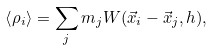<formula> <loc_0><loc_0><loc_500><loc_500>\left < \rho _ { i } \right > = \sum _ { j } m _ { j } W ( { \vec { x } _ { i } } - { \vec { x } _ { j } } , h ) ,</formula> 